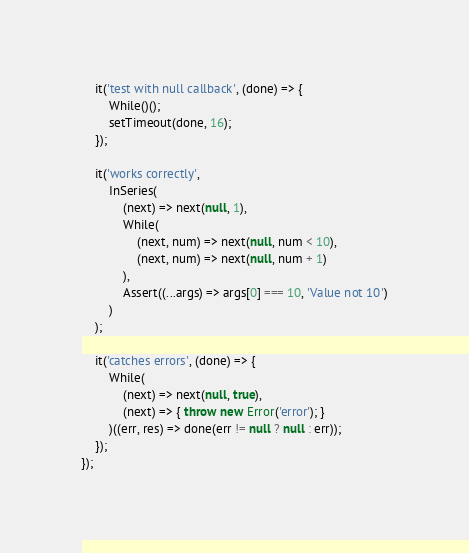Convert code to text. <code><loc_0><loc_0><loc_500><loc_500><_JavaScript_>	it('test with null callback', (done) => {
		While()();
		setTimeout(done, 16);
	});

	it('works correctly',
		InSeries(
			(next) => next(null, 1),
			While(
				(next, num) => next(null, num < 10),
				(next, num) => next(null, num + 1)
			),
			Assert((...args) => args[0] === 10, 'Value not 10')
		)
	);

	it('catches errors', (done) => {
		While(
			(next) => next(null, true),
			(next) => { throw new Error('error'); }
		)((err, res) => done(err != null ? null : err));
	});
});
</code> 